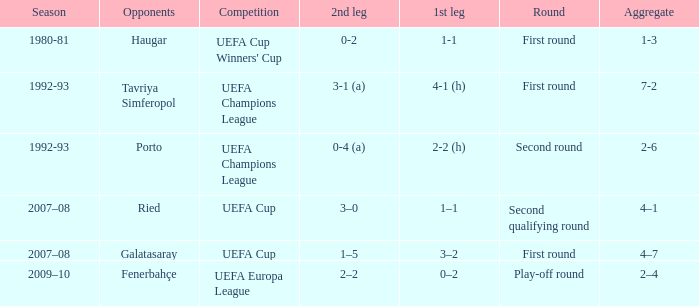Parse the full table. {'header': ['Season', 'Opponents', 'Competition', '2nd leg', '1st leg', 'Round', 'Aggregate'], 'rows': [['1980-81', 'Haugar', "UEFA Cup Winners' Cup", '0-2', '1-1', 'First round', '1-3'], ['1992-93', 'Tavriya Simferopol', 'UEFA Champions League', '3-1 (a)', '4-1 (h)', 'First round', '7-2'], ['1992-93', 'Porto', 'UEFA Champions League', '0-4 (a)', '2-2 (h)', 'Second round', '2-6'], ['2007–08', 'Ried', 'UEFA Cup', '3–0', '1–1', 'Second qualifying round', '4–1'], ['2007–08', 'Galatasaray', 'UEFA Cup', '1–5', '3–2', 'First round', '4–7'], ['2009–10', 'Fenerbahçe', 'UEFA Europa League', '2–2', '0–2', 'Play-off round', '2–4']]}  what's the competition where aggregate is 4–7 UEFA Cup. 